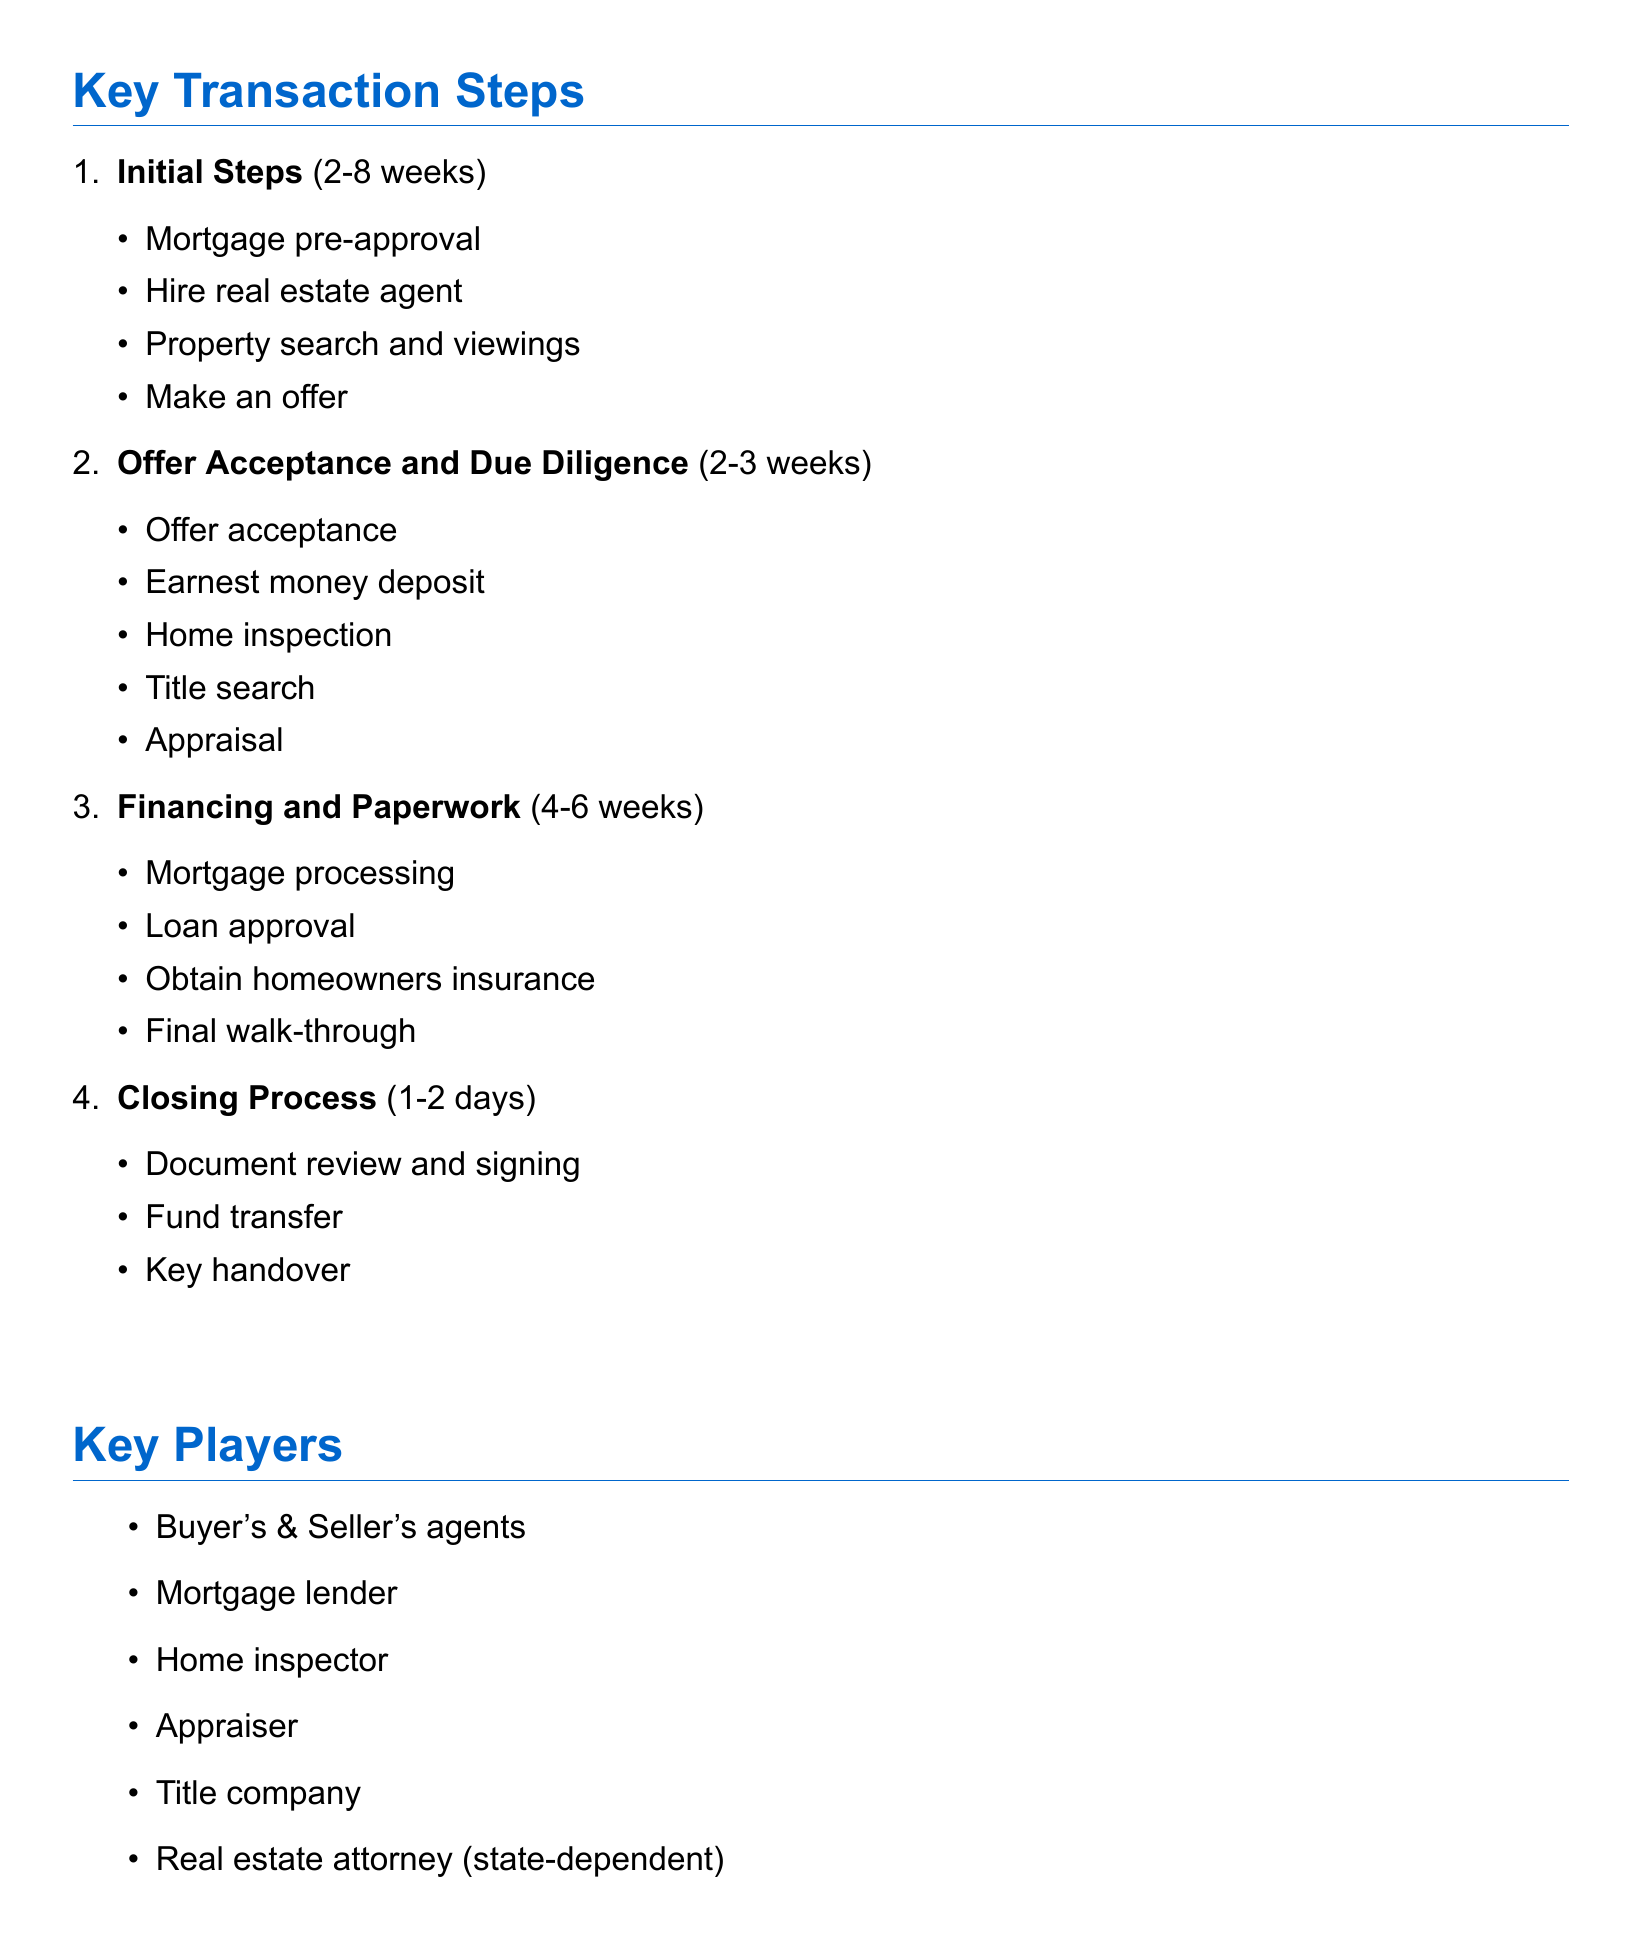What is the first step a buyer should take? The document lists "Buyer obtains pre-approval for mortgage" as the first initial step.
Answer: Buyer obtains pre-approval for mortgage How many days does it typically take to hire a real estate agent? The document states that hiring a real estate agent can take between 1 to 7 days.
Answer: 1-7 days What is the typical time frame for closing after an offer is accepted? The document mentions that the closing date is set 30-60 days from offer acceptance.
Answer: 30-60 days Which step involves scheduling a home inspection? The home inspection is part of the "Offer Acceptance and Due Diligence" section, specifically after the offer is accepted.
Answer: Offer Acceptance and Due Diligence Name one key player in a real estate transaction. The document lists several key players, including the buyer's agent.
Answer: Buyer's agent What are two common contingencies in US real estate contracts? The document lists several contingencies, including financing contingency and home inspection contingency.
Answer: Financing contingency, Home inspection contingency How long can the mortgage application processing take? The document states that mortgage application processing can take 30-45 days.
Answer: 30-45 days What is a typical closing cost? The document provides "loan origination fees" as one example of a typical closing cost.
Answer: Loan origination fees Who usually pays the real estate agent commissions? According to the document, the real estate agent commissions are usually paid by the seller.
Answer: Seller 